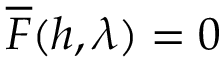Convert formula to latex. <formula><loc_0><loc_0><loc_500><loc_500>\overline { F } ( h , \lambda ) = 0</formula> 